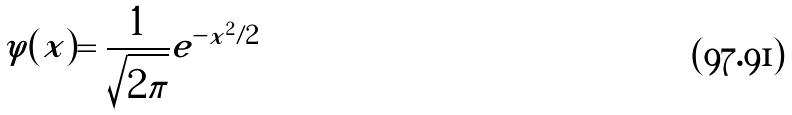Convert formula to latex. <formula><loc_0><loc_0><loc_500><loc_500>\varphi ( x ) = \frac { 1 } { \sqrt { 2 \pi } } e ^ { - x ^ { 2 } / 2 }</formula> 